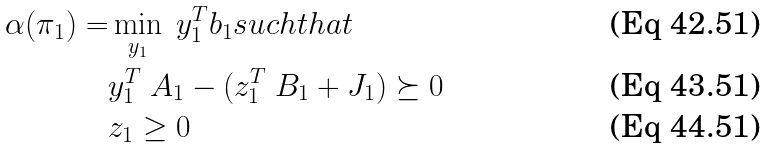<formula> <loc_0><loc_0><loc_500><loc_500>\alpha ( \pi _ { 1 } ) = & \min _ { y _ { 1 } } \ y _ { 1 } ^ { T } b _ { 1 } s u c h t h a t \\ & y _ { 1 } ^ { T } \ A _ { 1 } - ( z _ { 1 } ^ { T } \ B _ { 1 } + J _ { 1 } ) \succeq 0 \\ & z _ { 1 } \geq 0</formula> 